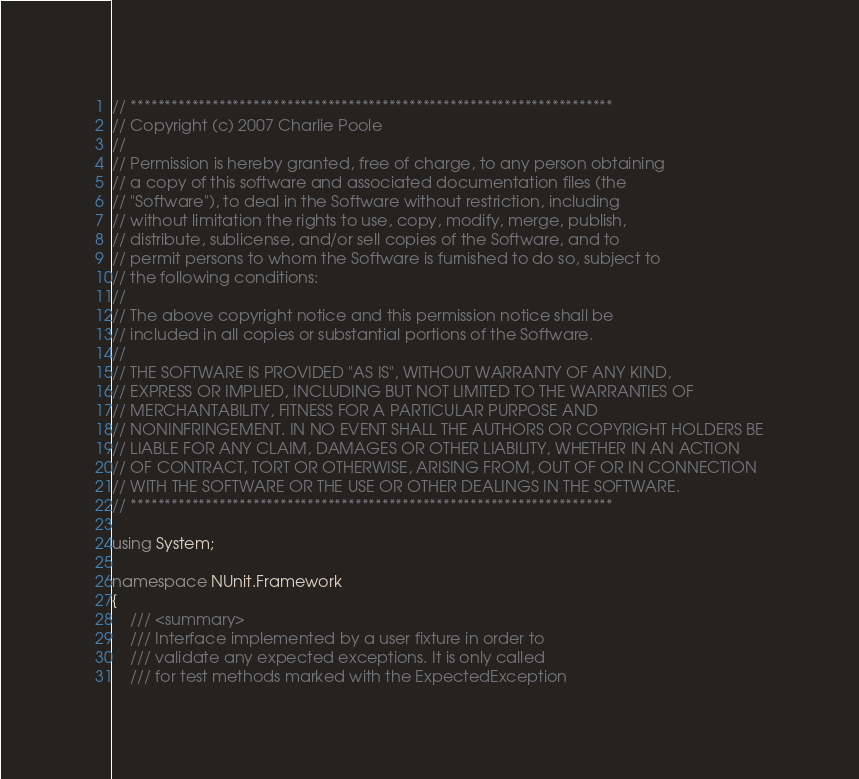Convert code to text. <code><loc_0><loc_0><loc_500><loc_500><_C#_>// ***********************************************************************
// Copyright (c) 2007 Charlie Poole
//
// Permission is hereby granted, free of charge, to any person obtaining
// a copy of this software and associated documentation files (the
// "Software"), to deal in the Software without restriction, including
// without limitation the rights to use, copy, modify, merge, publish,
// distribute, sublicense, and/or sell copies of the Software, and to
// permit persons to whom the Software is furnished to do so, subject to
// the following conditions:
// 
// The above copyright notice and this permission notice shall be
// included in all copies or substantial portions of the Software.
// 
// THE SOFTWARE IS PROVIDED "AS IS", WITHOUT WARRANTY OF ANY KIND,
// EXPRESS OR IMPLIED, INCLUDING BUT NOT LIMITED TO THE WARRANTIES OF
// MERCHANTABILITY, FITNESS FOR A PARTICULAR PURPOSE AND
// NONINFRINGEMENT. IN NO EVENT SHALL THE AUTHORS OR COPYRIGHT HOLDERS BE
// LIABLE FOR ANY CLAIM, DAMAGES OR OTHER LIABILITY, WHETHER IN AN ACTION
// OF CONTRACT, TORT OR OTHERWISE, ARISING FROM, OUT OF OR IN CONNECTION
// WITH THE SOFTWARE OR THE USE OR OTHER DEALINGS IN THE SOFTWARE.
// ***********************************************************************

using System;

namespace NUnit.Framework
{
    /// <summary>
    /// Interface implemented by a user fixture in order to
    /// validate any expected exceptions. It is only called
    /// for test methods marked with the ExpectedException</code> 